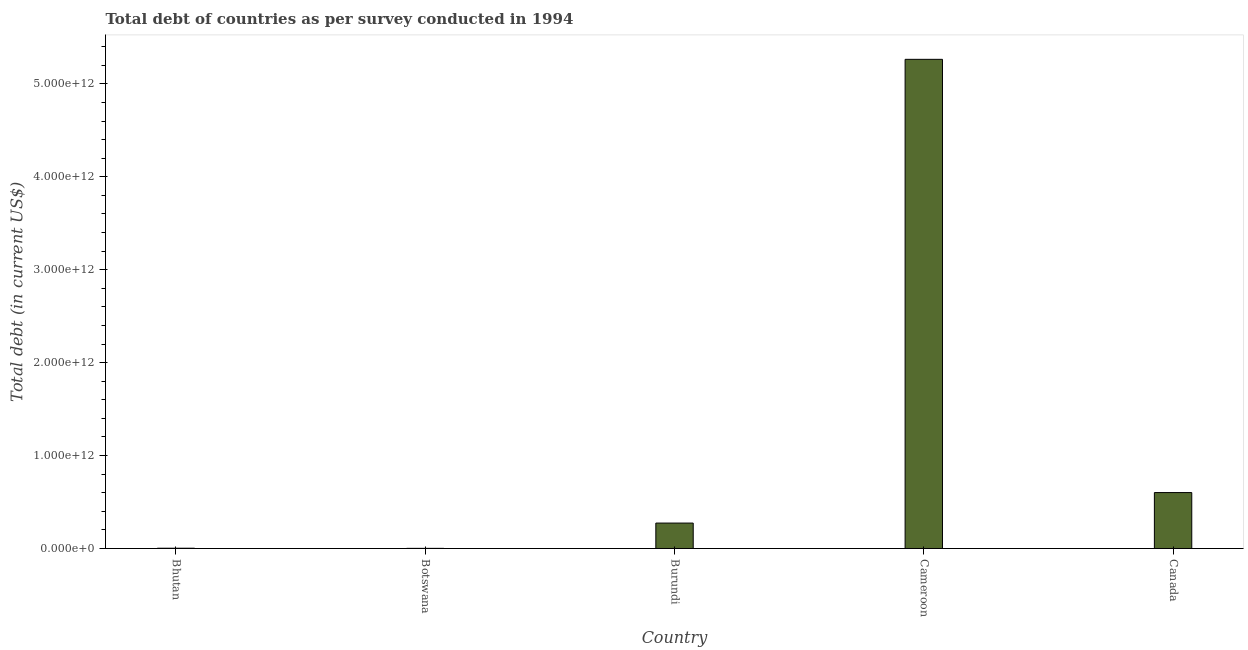Does the graph contain grids?
Keep it short and to the point. No. What is the title of the graph?
Keep it short and to the point. Total debt of countries as per survey conducted in 1994. What is the label or title of the Y-axis?
Ensure brevity in your answer.  Total debt (in current US$). What is the total debt in Canada?
Your answer should be very brief. 6.02e+11. Across all countries, what is the maximum total debt?
Your response must be concise. 5.26e+12. Across all countries, what is the minimum total debt?
Make the answer very short. 1.38e+09. In which country was the total debt maximum?
Ensure brevity in your answer.  Cameroon. In which country was the total debt minimum?
Provide a succinct answer. Botswana. What is the sum of the total debt?
Provide a succinct answer. 6.14e+12. What is the difference between the total debt in Burundi and Cameroon?
Your answer should be compact. -4.99e+12. What is the average total debt per country?
Offer a terse response. 1.23e+12. What is the median total debt?
Keep it short and to the point. 2.73e+11. What is the ratio of the total debt in Bhutan to that in Canada?
Offer a terse response. 0.01. What is the difference between the highest and the second highest total debt?
Provide a succinct answer. 4.66e+12. Is the sum of the total debt in Cameroon and Canada greater than the maximum total debt across all countries?
Keep it short and to the point. Yes. What is the difference between the highest and the lowest total debt?
Provide a short and direct response. 5.26e+12. In how many countries, is the total debt greater than the average total debt taken over all countries?
Provide a short and direct response. 1. Are all the bars in the graph horizontal?
Offer a terse response. No. How many countries are there in the graph?
Make the answer very short. 5. What is the difference between two consecutive major ticks on the Y-axis?
Your answer should be compact. 1.00e+12. Are the values on the major ticks of Y-axis written in scientific E-notation?
Make the answer very short. Yes. What is the Total debt (in current US$) in Bhutan?
Your answer should be very brief. 2.80e+09. What is the Total debt (in current US$) of Botswana?
Provide a succinct answer. 1.38e+09. What is the Total debt (in current US$) in Burundi?
Your answer should be very brief. 2.73e+11. What is the Total debt (in current US$) in Cameroon?
Your answer should be compact. 5.26e+12. What is the Total debt (in current US$) of Canada?
Your response must be concise. 6.02e+11. What is the difference between the Total debt (in current US$) in Bhutan and Botswana?
Your response must be concise. 1.42e+09. What is the difference between the Total debt (in current US$) in Bhutan and Burundi?
Offer a very short reply. -2.71e+11. What is the difference between the Total debt (in current US$) in Bhutan and Cameroon?
Your answer should be very brief. -5.26e+12. What is the difference between the Total debt (in current US$) in Bhutan and Canada?
Keep it short and to the point. -5.99e+11. What is the difference between the Total debt (in current US$) in Botswana and Burundi?
Ensure brevity in your answer.  -2.72e+11. What is the difference between the Total debt (in current US$) in Botswana and Cameroon?
Offer a terse response. -5.26e+12. What is the difference between the Total debt (in current US$) in Botswana and Canada?
Provide a short and direct response. -6.00e+11. What is the difference between the Total debt (in current US$) in Burundi and Cameroon?
Keep it short and to the point. -4.99e+12. What is the difference between the Total debt (in current US$) in Burundi and Canada?
Keep it short and to the point. -3.28e+11. What is the difference between the Total debt (in current US$) in Cameroon and Canada?
Make the answer very short. 4.66e+12. What is the ratio of the Total debt (in current US$) in Bhutan to that in Botswana?
Provide a short and direct response. 2.03. What is the ratio of the Total debt (in current US$) in Bhutan to that in Cameroon?
Give a very brief answer. 0. What is the ratio of the Total debt (in current US$) in Bhutan to that in Canada?
Your response must be concise. 0.01. What is the ratio of the Total debt (in current US$) in Botswana to that in Burundi?
Provide a succinct answer. 0.01. What is the ratio of the Total debt (in current US$) in Botswana to that in Cameroon?
Offer a very short reply. 0. What is the ratio of the Total debt (in current US$) in Botswana to that in Canada?
Your answer should be very brief. 0. What is the ratio of the Total debt (in current US$) in Burundi to that in Cameroon?
Ensure brevity in your answer.  0.05. What is the ratio of the Total debt (in current US$) in Burundi to that in Canada?
Ensure brevity in your answer.  0.46. What is the ratio of the Total debt (in current US$) in Cameroon to that in Canada?
Give a very brief answer. 8.75. 